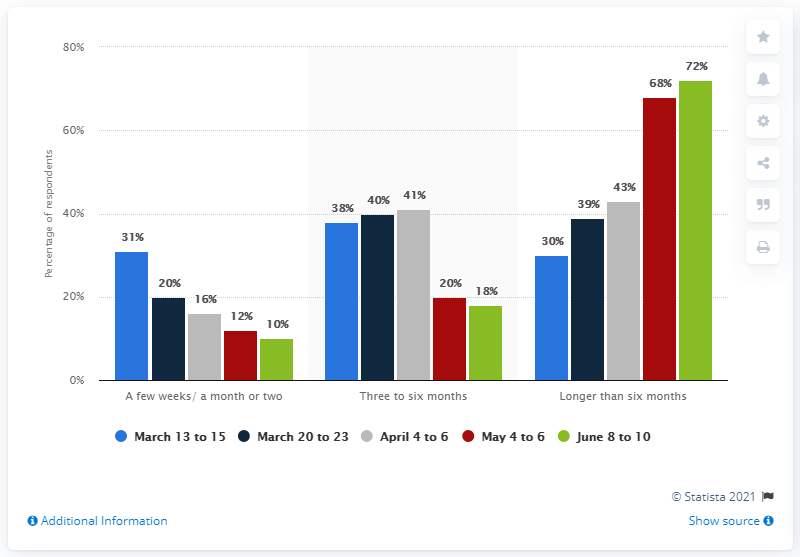Mention a couple of crucial points in this snapshot. According to a survey, a significant percentage of Canadians believed that it would only take a month or two for things to return to normal after the COVID-19 pandemic. 